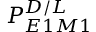Convert formula to latex. <formula><loc_0><loc_0><loc_500><loc_500>P _ { E 1 M 1 } ^ { D / L }</formula> 